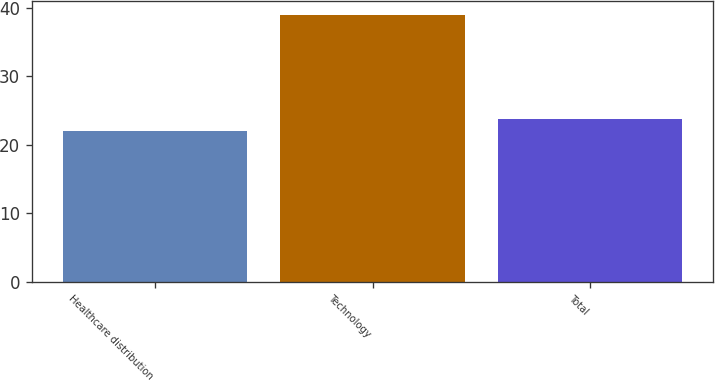Convert chart. <chart><loc_0><loc_0><loc_500><loc_500><bar_chart><fcel>Healthcare distribution<fcel>Technology<fcel>Total<nl><fcel>22<fcel>39<fcel>23.7<nl></chart> 